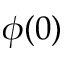Convert formula to latex. <formula><loc_0><loc_0><loc_500><loc_500>\phi ( 0 )</formula> 